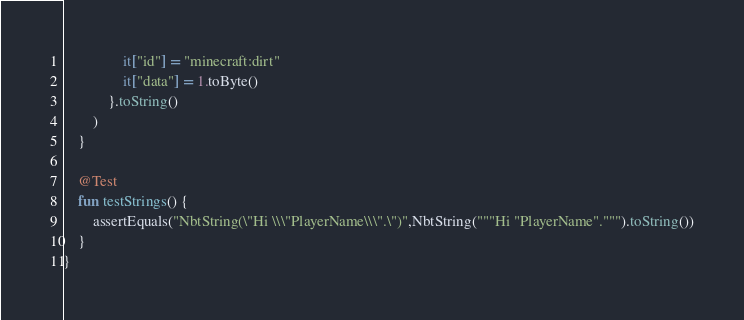Convert code to text. <code><loc_0><loc_0><loc_500><loc_500><_Kotlin_>                it["id"] = "minecraft:dirt"
                it["data"] = 1.toByte()
            }.toString()
        )
    }

    @Test
    fun testStrings() {
        assertEquals("NbtString(\"Hi \\\"PlayerName\\\".\")",NbtString("""Hi "PlayerName".""").toString())
    }
}
</code> 